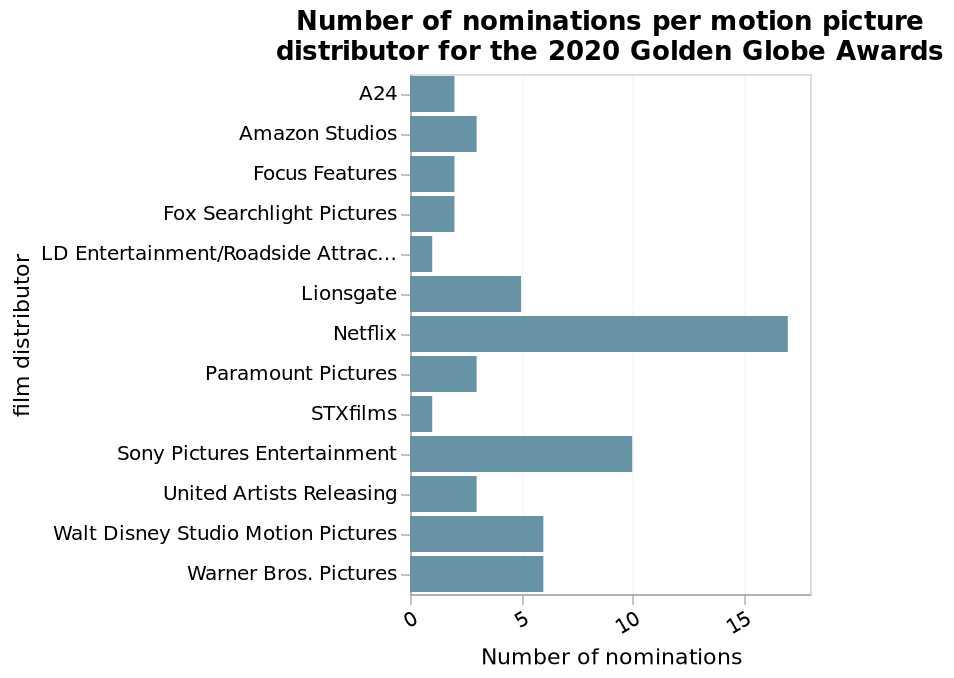<image>
please describe the details of the chart Number of nominations per motion picture distributor for the 2020 Golden Globe Awards is a bar graph. The x-axis measures Number of nominations while the y-axis plots film distributor. What does the x-axis measure in the bar graph? The x-axis measures the number of nominations. What does the y-axis represent in the bar graph? The y-axis represents film distributor. 